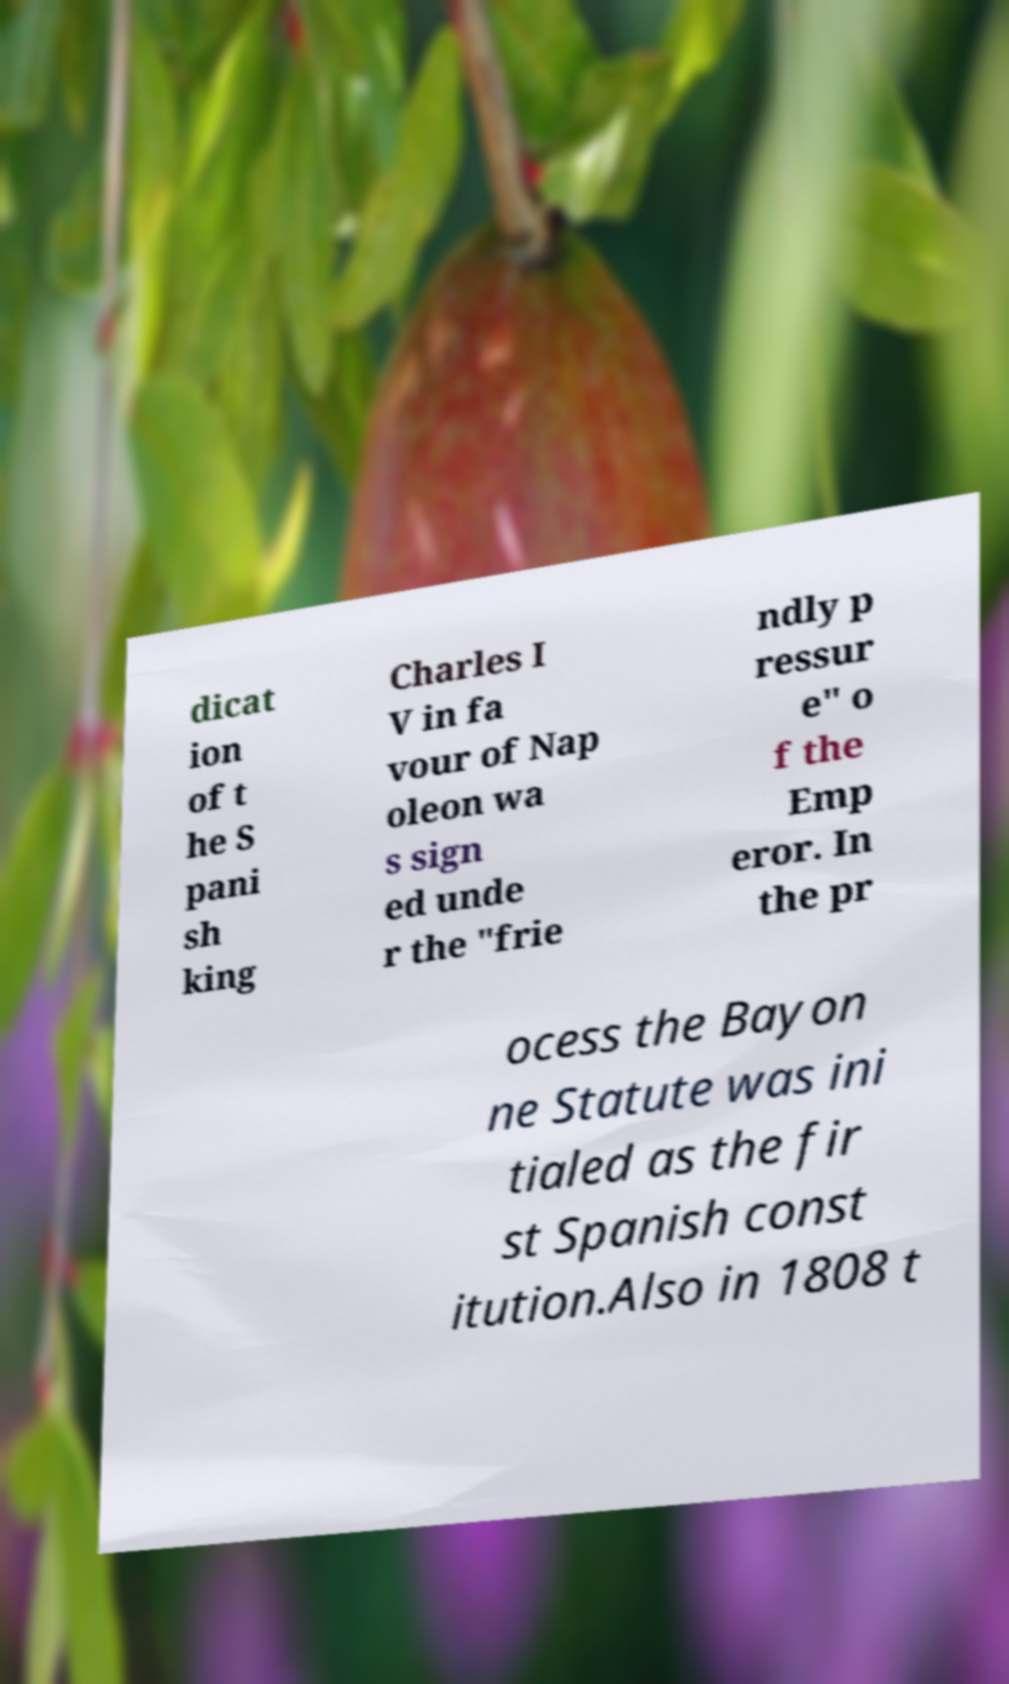What messages or text are displayed in this image? I need them in a readable, typed format. dicat ion of t he S pani sh king Charles I V in fa vour of Nap oleon wa s sign ed unde r the "frie ndly p ressur e" o f the Emp eror. In the pr ocess the Bayon ne Statute was ini tialed as the fir st Spanish const itution.Also in 1808 t 